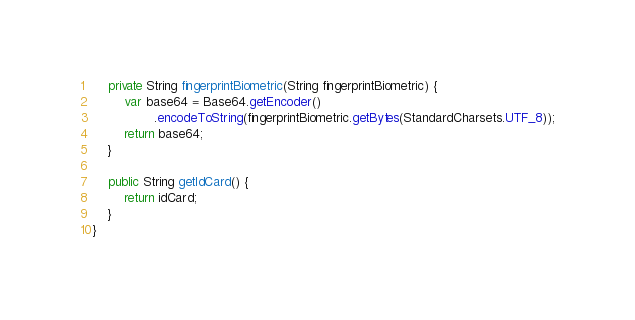Convert code to text. <code><loc_0><loc_0><loc_500><loc_500><_Java_>
    private String fingerprintBiometric(String fingerprintBiometric) {
        var base64 = Base64.getEncoder()
                .encodeToString(fingerprintBiometric.getBytes(StandardCharsets.UTF_8));
        return base64;
    }

    public String getIdCard() {
        return idCard;
    }
}
</code> 